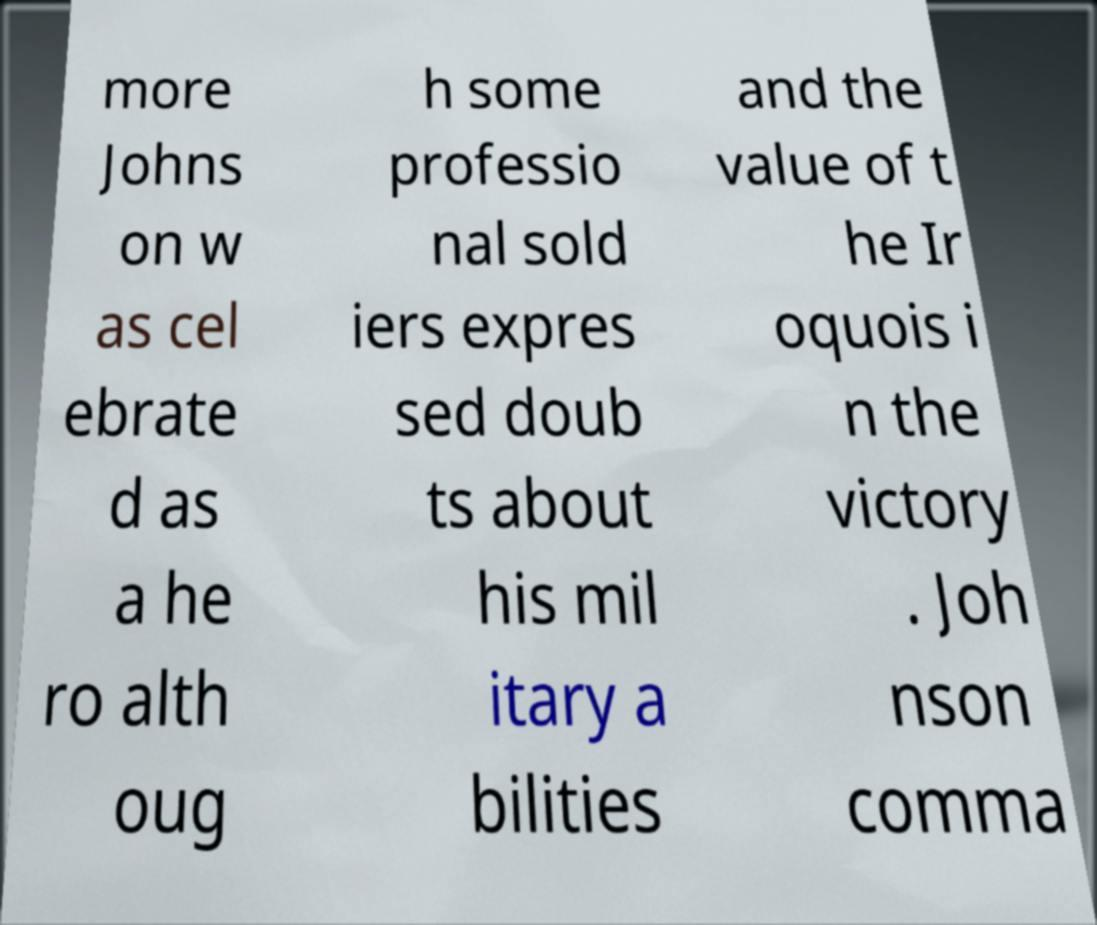Please identify and transcribe the text found in this image. more Johns on w as cel ebrate d as a he ro alth oug h some professio nal sold iers expres sed doub ts about his mil itary a bilities and the value of t he Ir oquois i n the victory . Joh nson comma 